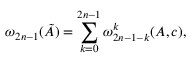<formula> <loc_0><loc_0><loc_500><loc_500>\omega _ { 2 n - 1 } ( \tilde { A } ) = \sum _ { k = 0 } ^ { 2 n - 1 } \omega _ { 2 n - 1 - k } ^ { k } ( A , c ) ,</formula> 